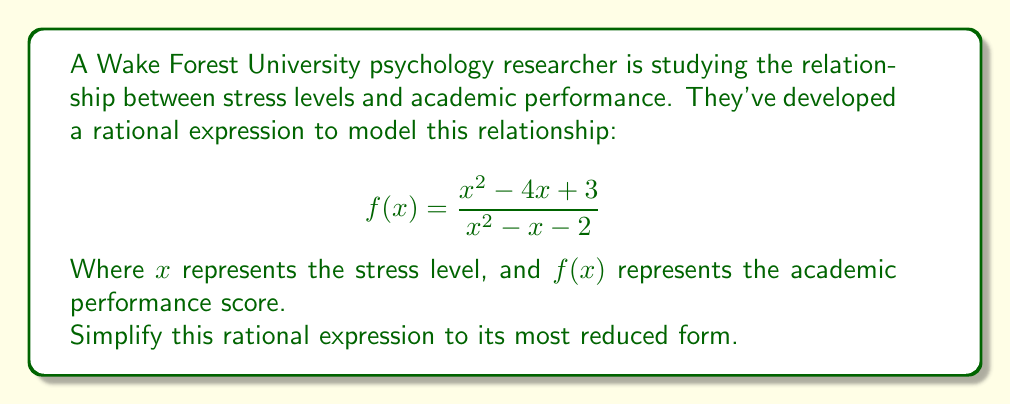What is the answer to this math problem? To simplify this rational expression, we'll follow these steps:

1) First, let's factor both the numerator and denominator:

   Numerator: $x^2 - 4x + 3 = (x - 3)(x - 1)$
   Denominator: $x^2 - x - 2 = (x - 2)(x + 1)$

2) Now our expression looks like this:

   $$f(x) = \frac{(x - 3)(x - 1)}{(x - 2)(x + 1)}$$

3) We can see that there are no common factors between the numerator and denominator, so this is the most simplified form of the rational expression.

4) However, we should note the restrictions on the domain. The denominator cannot equal zero, so:

   $x - 2 \neq 0$ and $x + 1 \neq 0$
   $x \neq 2$ and $x \neq -1$

Therefore, the domain of this function is all real numbers except 2 and -1.
Answer: $$f(x) = \frac{(x - 3)(x - 1)}{(x - 2)(x + 1)}, x \neq 2, x \neq -1$$ 